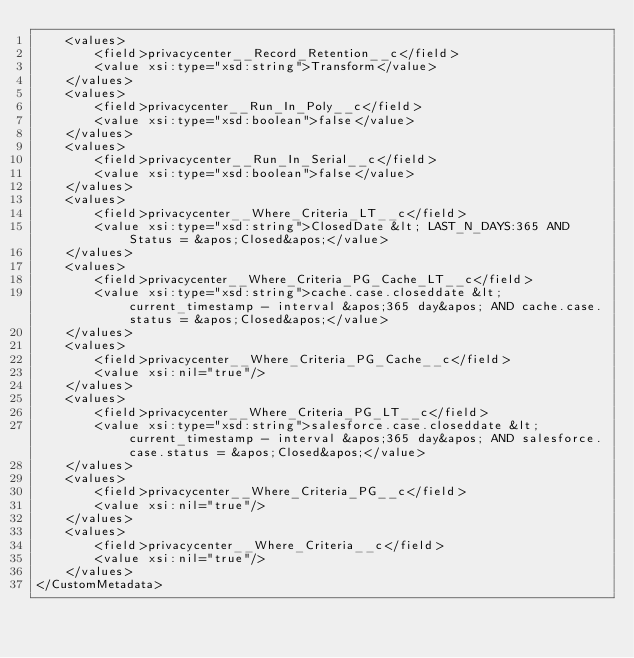<code> <loc_0><loc_0><loc_500><loc_500><_XML_>    <values>
        <field>privacycenter__Record_Retention__c</field>
        <value xsi:type="xsd:string">Transform</value>
    </values>
    <values>
        <field>privacycenter__Run_In_Poly__c</field>
        <value xsi:type="xsd:boolean">false</value>
    </values>
    <values>
        <field>privacycenter__Run_In_Serial__c</field>
        <value xsi:type="xsd:boolean">false</value>
    </values>
    <values>
        <field>privacycenter__Where_Criteria_LT__c</field>
        <value xsi:type="xsd:string">ClosedDate &lt; LAST_N_DAYS:365 AND Status = &apos;Closed&apos;</value>
    </values>
    <values>
        <field>privacycenter__Where_Criteria_PG_Cache_LT__c</field>
        <value xsi:type="xsd:string">cache.case.closeddate &lt; current_timestamp - interval &apos;365 day&apos; AND cache.case.status = &apos;Closed&apos;</value>
    </values>
    <values>
        <field>privacycenter__Where_Criteria_PG_Cache__c</field>
        <value xsi:nil="true"/>
    </values>
    <values>
        <field>privacycenter__Where_Criteria_PG_LT__c</field>
        <value xsi:type="xsd:string">salesforce.case.closeddate &lt; current_timestamp - interval &apos;365 day&apos; AND salesforce.case.status = &apos;Closed&apos;</value>
    </values>
    <values>
        <field>privacycenter__Where_Criteria_PG__c</field>
        <value xsi:nil="true"/>
    </values>
    <values>
        <field>privacycenter__Where_Criteria__c</field>
        <value xsi:nil="true"/>
    </values>
</CustomMetadata>
</code> 